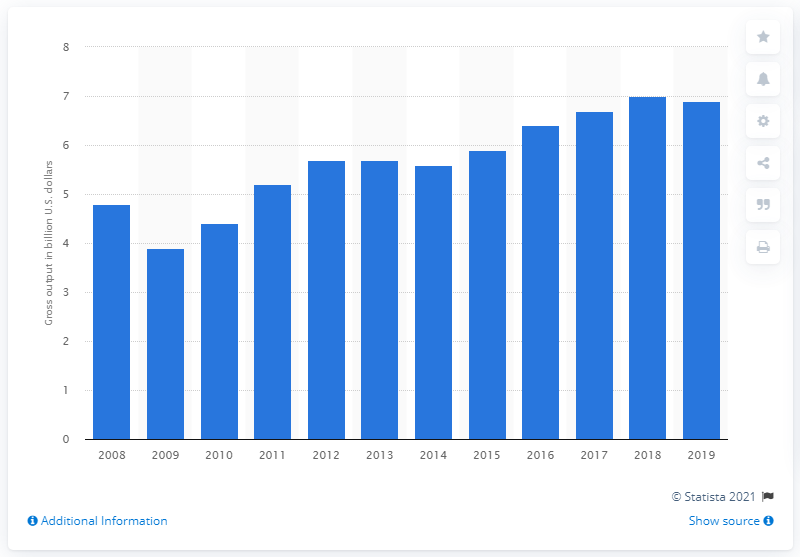Highlight a few significant elements in this photo. In 2019, the gross output of the packaging machinery manufacturing sector was $6.9 billion. 